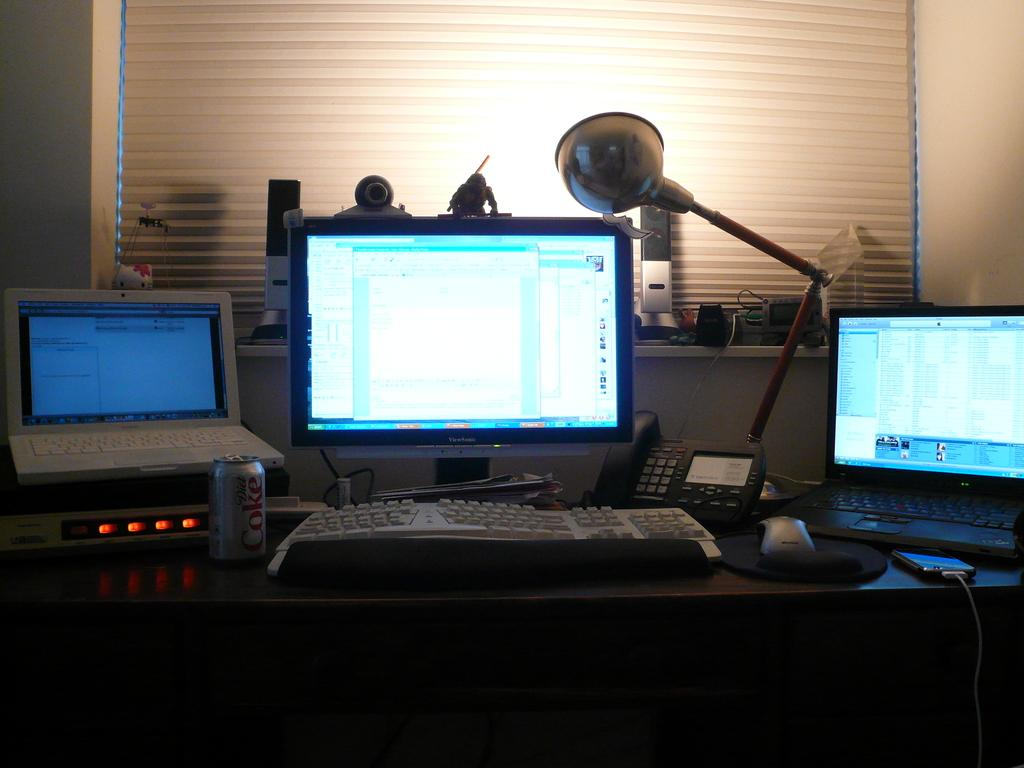What electronic device is visible in the image? There is a laptop in the image. What other electronic devices can be seen in the image? There is a mobile phone, a computer monitor, a keyboard, and a mouse in the image. What communication device is present in the image? There is a telephone in the image. What beverage container is visible in the image? There is a coke tin in the image. Where are the electronic devices placed in the image? The objects are placed on a table. What can be seen in the background of the image? There are blinds in the background of the image. How does the monkey feel about the things on the table in the image? There is no monkey present in the image, so it is not possible to determine how a monkey might feel about the objects on the table. 